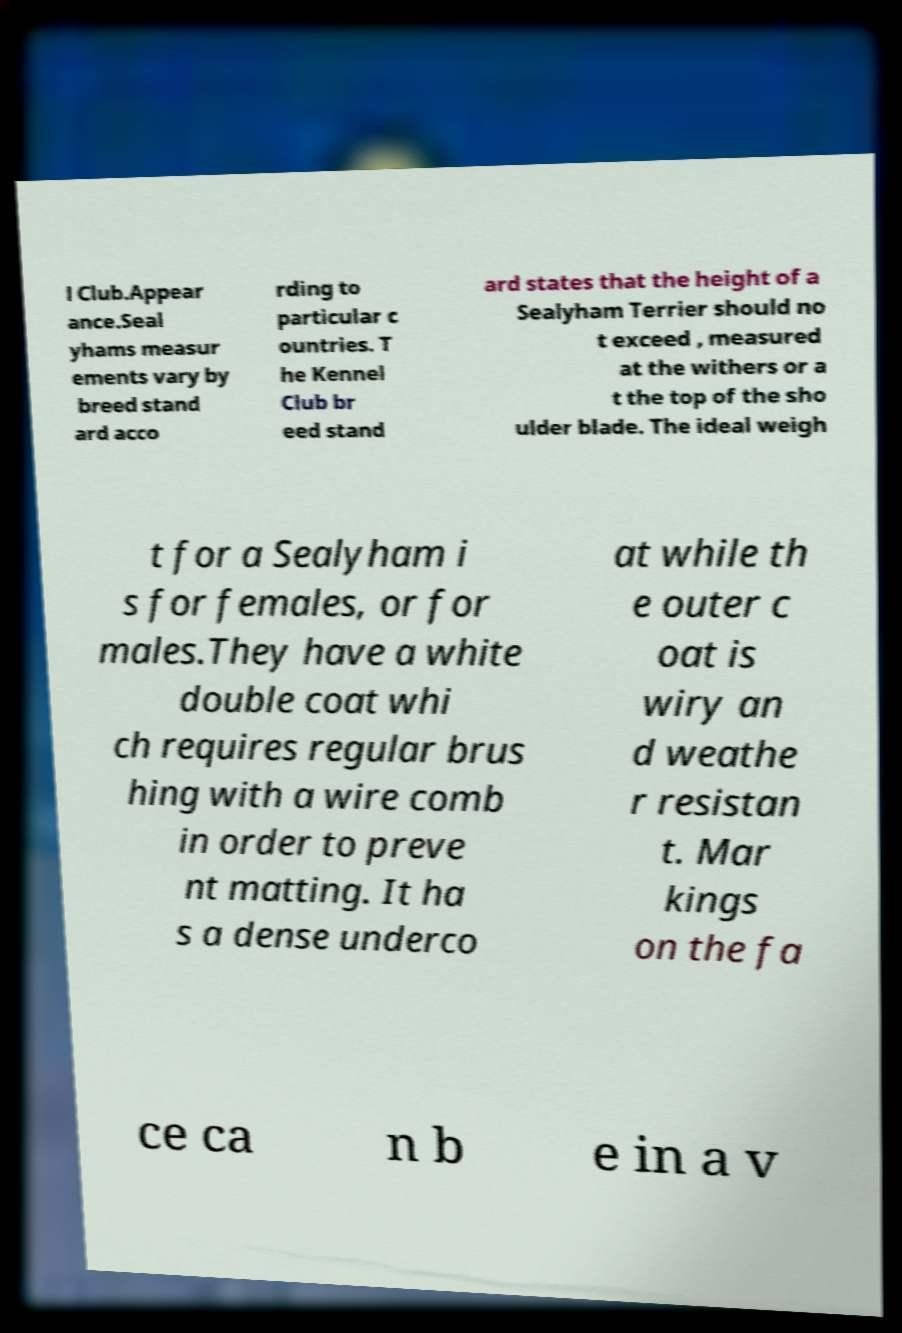For documentation purposes, I need the text within this image transcribed. Could you provide that? l Club.Appear ance.Seal yhams measur ements vary by breed stand ard acco rding to particular c ountries. T he Kennel Club br eed stand ard states that the height of a Sealyham Terrier should no t exceed , measured at the withers or a t the top of the sho ulder blade. The ideal weigh t for a Sealyham i s for females, or for males.They have a white double coat whi ch requires regular brus hing with a wire comb in order to preve nt matting. It ha s a dense underco at while th e outer c oat is wiry an d weathe r resistan t. Mar kings on the fa ce ca n b e in a v 